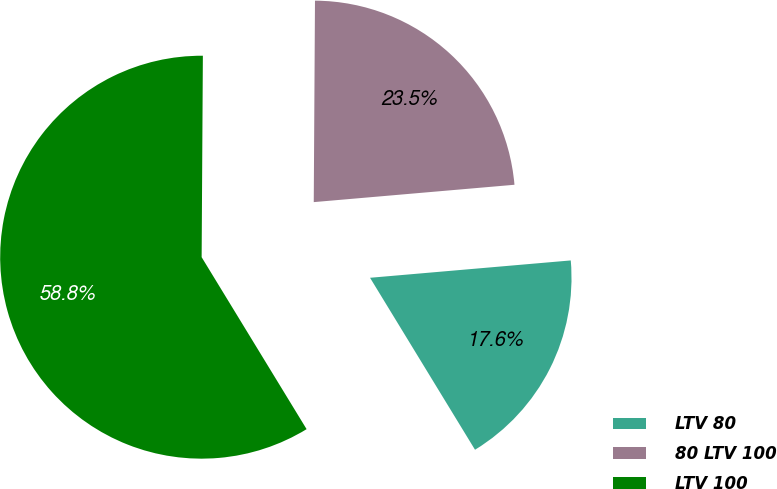Convert chart. <chart><loc_0><loc_0><loc_500><loc_500><pie_chart><fcel>LTV 80<fcel>80 LTV 100<fcel>LTV 100<nl><fcel>17.65%<fcel>23.53%<fcel>58.82%<nl></chart> 